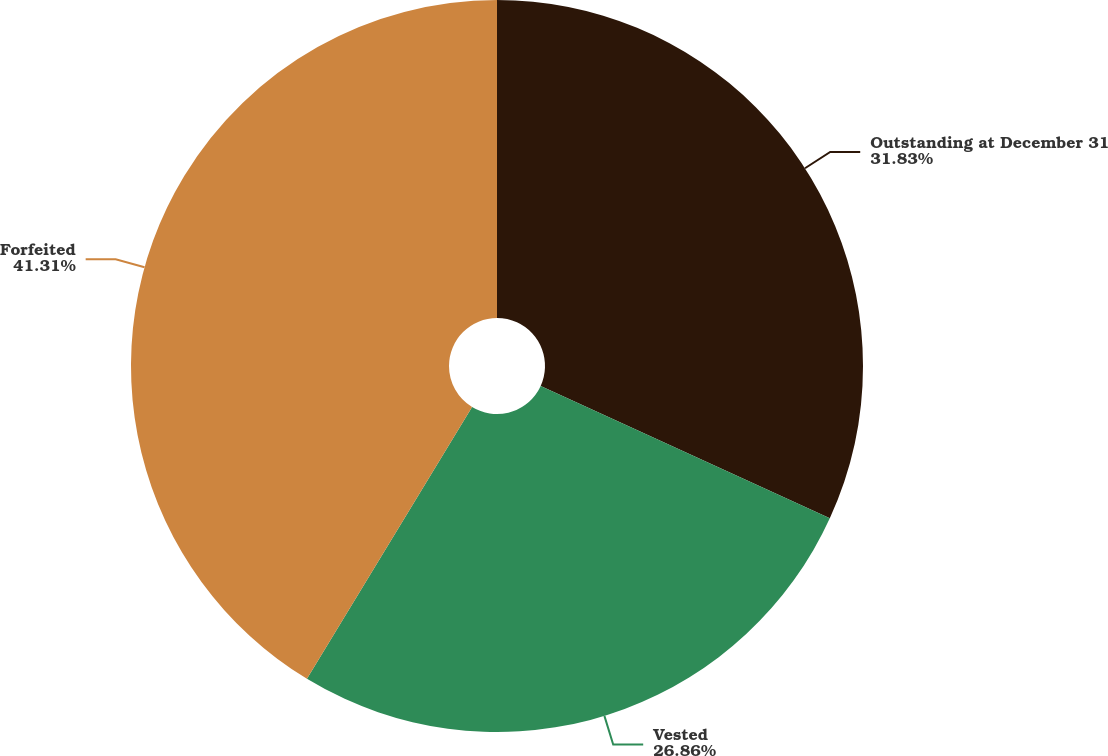Convert chart to OTSL. <chart><loc_0><loc_0><loc_500><loc_500><pie_chart><fcel>Outstanding at December 31<fcel>Vested<fcel>Forfeited<nl><fcel>31.83%<fcel>26.86%<fcel>41.31%<nl></chart> 